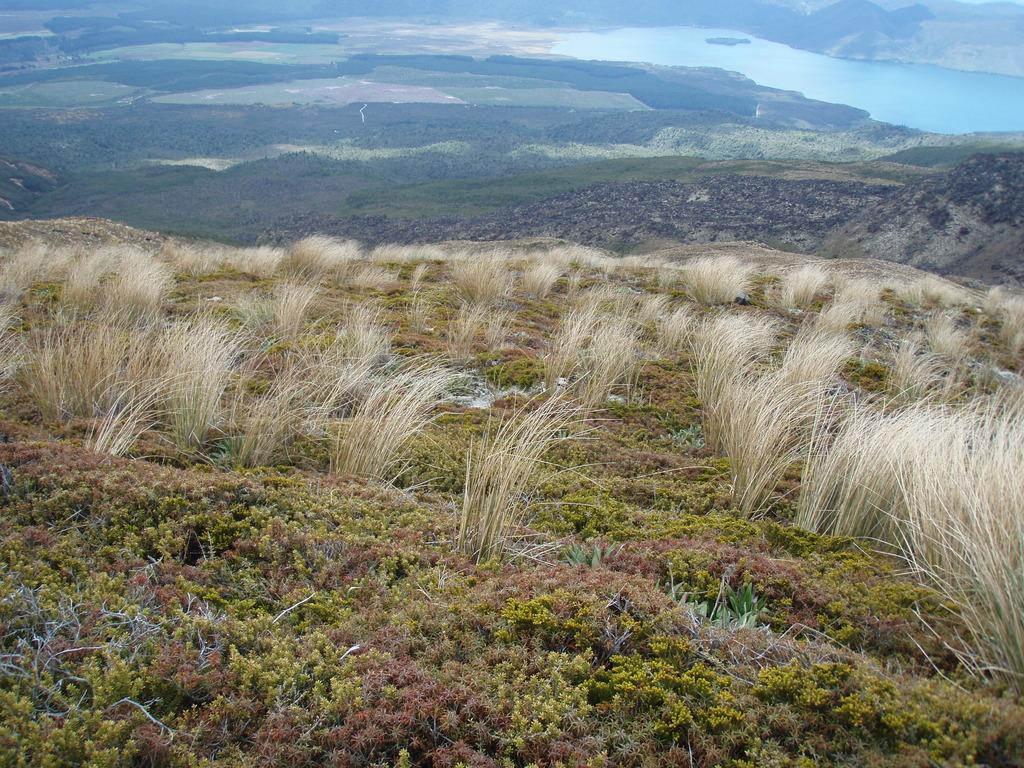What type of vegetation is present in the image? There are so many plants in the image. What can be seen in the background of the image? There is grass and water visible in the background of the image. What type of glue is being used to hold the plants together in the image? There is no glue present in the image; the plants are naturally growing. 